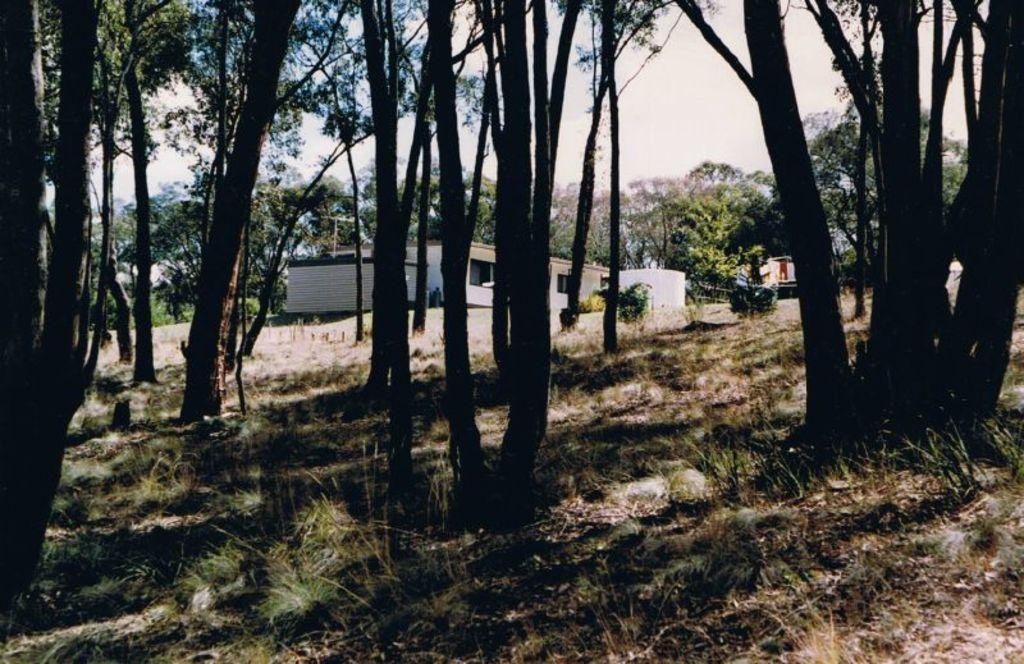What can be seen in the sky in the image? Sky is visible in the image, and clouds are present. What type of natural elements can be seen in the image? Trees, plants, and grass are visible in the image. What type of structures are visible in the image? Buildings are visible in the image. What architectural features can be seen in the buildings? Windows are present in the image. What type of dress is the father wearing in the image? There is no father or dress present in the image. What is the wealth status of the person in the image? There is no person or indication of wealth status in the image. 